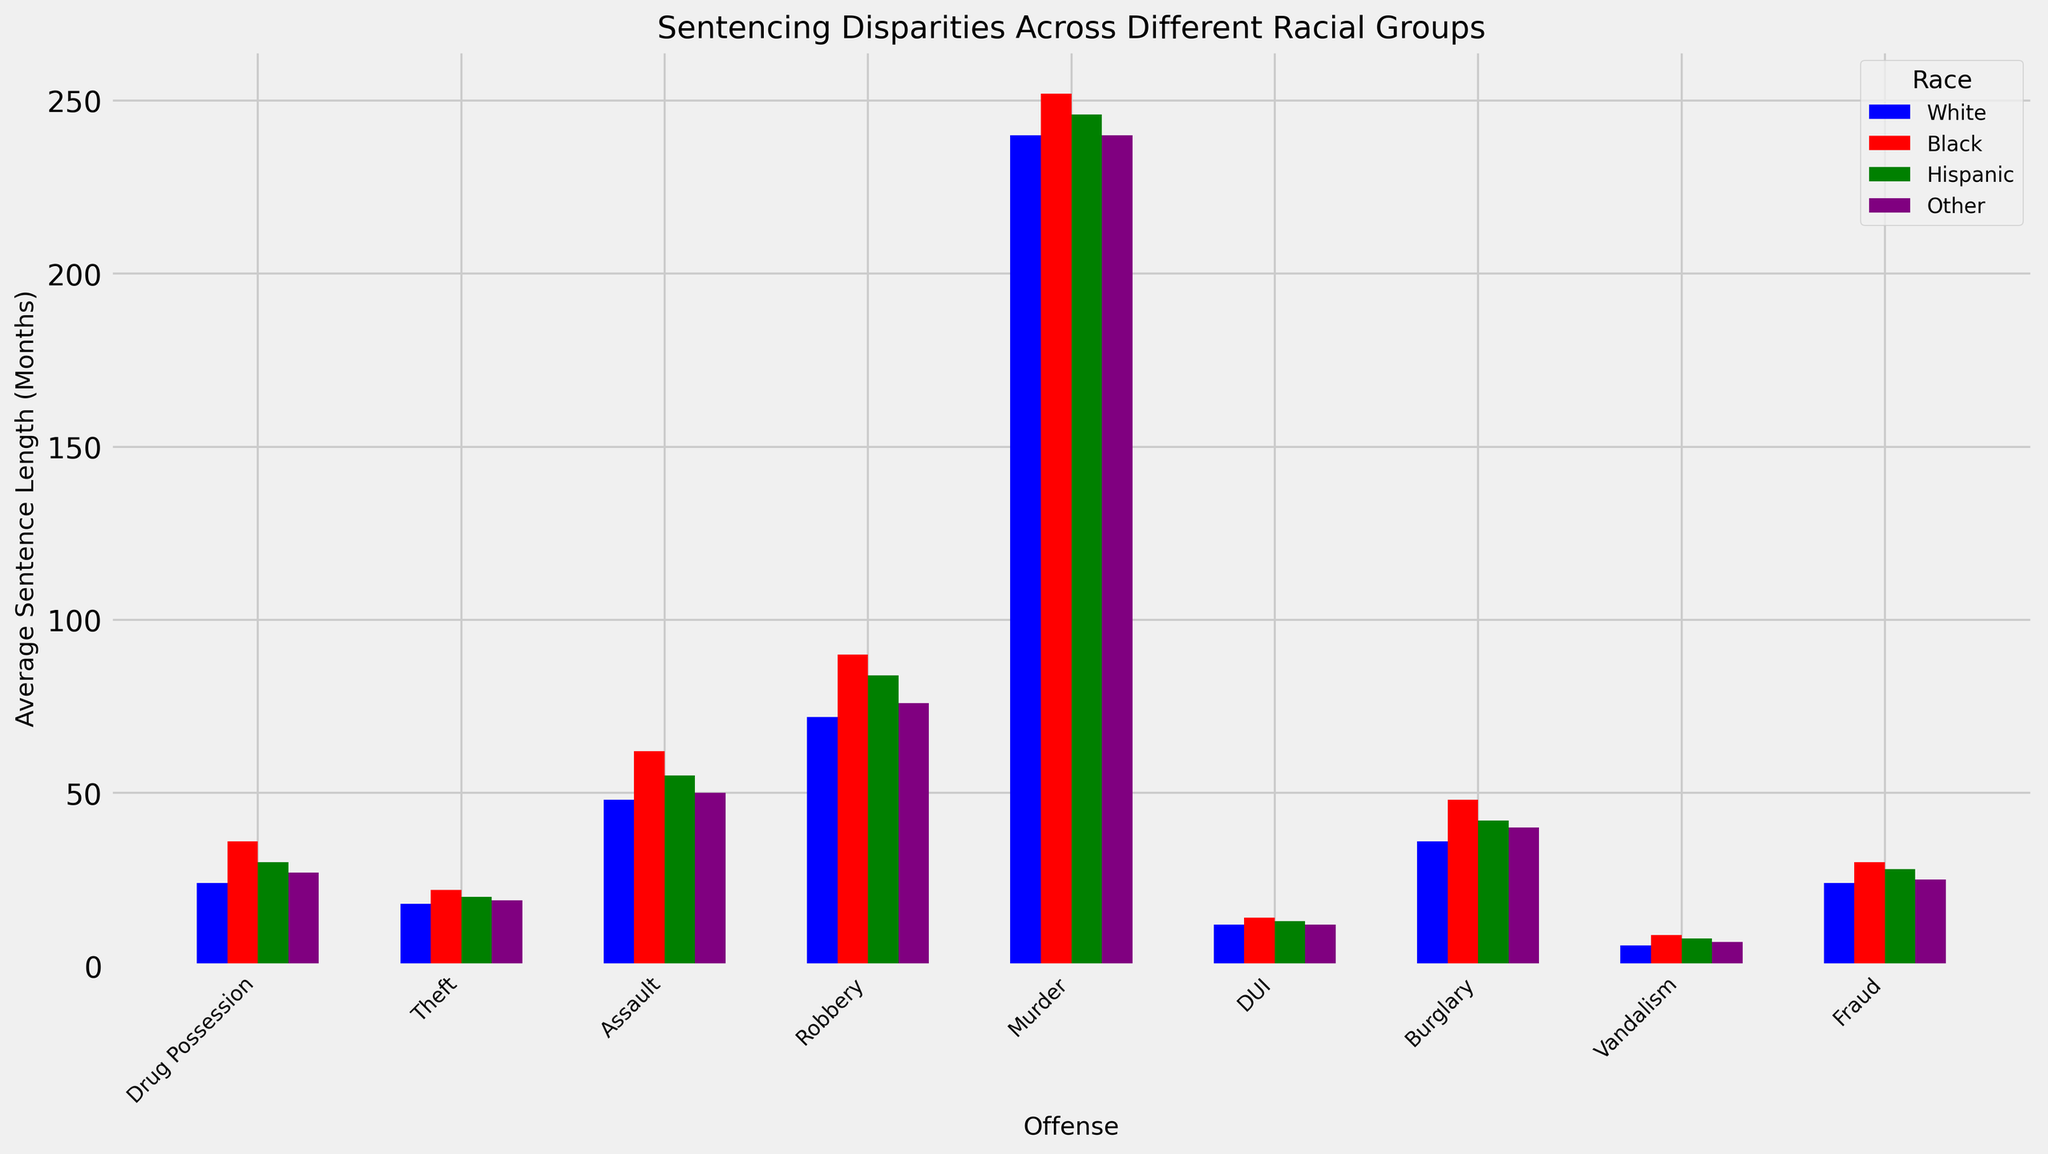What's the average sentence length for Drug Possession across all racial groups? The average sentence length for Drug Possession across all racial groups can be found by averaging the sentence lengths for White (24), Black (36), Hispanic (30), and Other (27). Sum these values (24 + 36 + 30 + 27 = 117) and then divide by the number of racial groups (4). So, the average is 117/4 = 29.25
Answer: 29.25 Which racial group has the highest average sentence length for Assault? To find this, look at the bars representing Assault. The heights are: White (48), Black (62), Hispanic (55), and Other (50). The highest value is 62 for Black.
Answer: Black What is the difference in average sentence length for Robbery between Black and White individuals? The average sentence lengths for Robbery are 90 months for Black individuals and 72 months for White individuals. The difference is 90 - 72 = 18 months.
Answer: 18 months Which offense has the least sentence disparity among racial groups? To identify this offense, find the offense where the heights of the bars are closest to each other. For example, Murder has values of 240 (White), 252 (Black), 246 (Hispanic), and 240 (Other), showing little disparity.
Answer: Murder Compare the average sentence length for Fraud between Hispanic and Other racial groups. Which is higher, and by how much? The average sentence length for Fraud is 28 months for Hispanic and 25 months for Other racial groups. Hispanic is higher by 28 - 25 = 3 months.
Answer: Hispanic, 3 months Which racial group receives the shortest average sentence for Vandalism? By looking at the Vandalism bars, the heights are 6 (White), 9 (Black), 8 (Hispanic), and 7 (Other). The shortest sentence is for White at 6 months.
Answer: White How much longer is the average sentence for Burglary for Black individuals compared to White individuals? The average sentence lengths for Burglary are 48 months for Black individuals and 36 months for White individuals. The difference is 48 - 36 = 12 months.
Answer: 12 months For Drug Possession, how does the average sentence length for Hispanic individuals compare to the average for Other racial groups? The average sentence length for Drug Possession is 30 months for Hispanic individuals and 27 months for Other racial groups. Hispanic individuals have a longer sentence by 3 months.
Answer: 3 months Which offense shows the highest sentence length for Hispanic individuals? By comparing the bars for Hispanic individuals across all offenses, the highest value is for Murder with a sentence length of 246 months.
Answer: Murder 